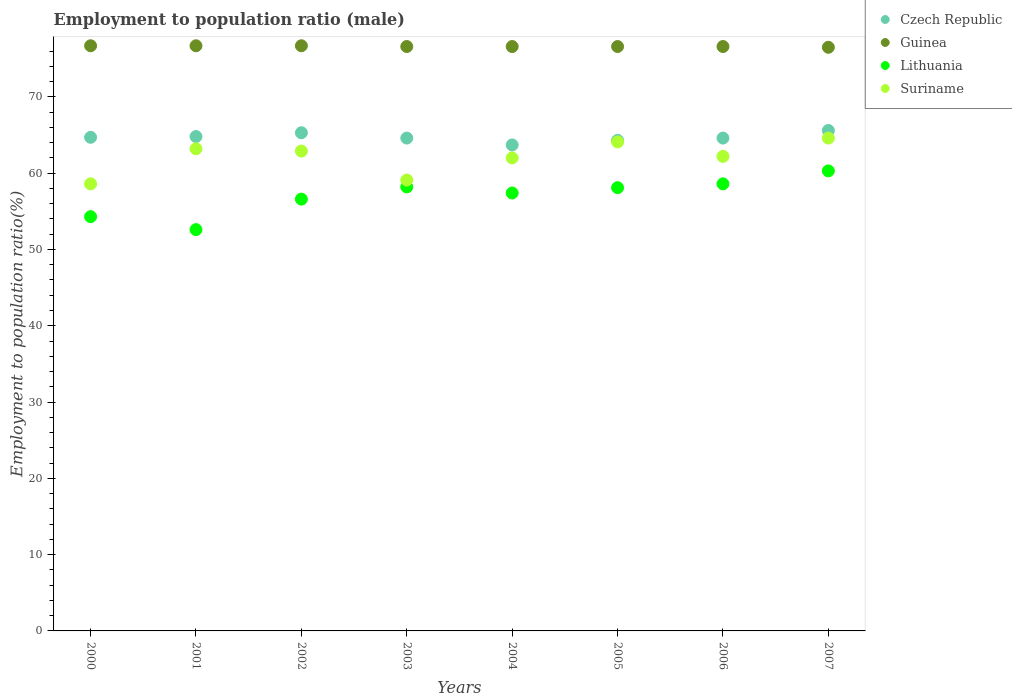What is the employment to population ratio in Suriname in 2006?
Give a very brief answer. 62.2. Across all years, what is the maximum employment to population ratio in Czech Republic?
Provide a short and direct response. 65.6. Across all years, what is the minimum employment to population ratio in Guinea?
Make the answer very short. 76.5. What is the total employment to population ratio in Guinea in the graph?
Ensure brevity in your answer.  613. What is the difference between the employment to population ratio in Lithuania in 2002 and that in 2005?
Your answer should be very brief. -1.5. What is the difference between the employment to population ratio in Suriname in 2003 and the employment to population ratio in Lithuania in 2005?
Provide a succinct answer. 1. What is the average employment to population ratio in Suriname per year?
Your answer should be very brief. 62.09. In the year 2002, what is the difference between the employment to population ratio in Guinea and employment to population ratio in Czech Republic?
Keep it short and to the point. 11.4. In how many years, is the employment to population ratio in Lithuania greater than 54 %?
Offer a very short reply. 7. What is the ratio of the employment to population ratio in Czech Republic in 2002 to that in 2003?
Keep it short and to the point. 1.01. Is the difference between the employment to population ratio in Guinea in 2001 and 2004 greater than the difference between the employment to population ratio in Czech Republic in 2001 and 2004?
Your answer should be very brief. No. What is the difference between the highest and the lowest employment to population ratio in Czech Republic?
Provide a short and direct response. 1.9. In how many years, is the employment to population ratio in Guinea greater than the average employment to population ratio in Guinea taken over all years?
Make the answer very short. 3. Is the sum of the employment to population ratio in Lithuania in 2001 and 2003 greater than the maximum employment to population ratio in Guinea across all years?
Provide a short and direct response. Yes. Is it the case that in every year, the sum of the employment to population ratio in Lithuania and employment to population ratio in Guinea  is greater than the sum of employment to population ratio in Suriname and employment to population ratio in Czech Republic?
Your answer should be very brief. Yes. How many dotlines are there?
Provide a succinct answer. 4. How many years are there in the graph?
Your answer should be very brief. 8. What is the difference between two consecutive major ticks on the Y-axis?
Provide a succinct answer. 10. Does the graph contain grids?
Offer a terse response. No. How many legend labels are there?
Keep it short and to the point. 4. What is the title of the graph?
Provide a succinct answer. Employment to population ratio (male). Does "Trinidad and Tobago" appear as one of the legend labels in the graph?
Ensure brevity in your answer.  No. What is the Employment to population ratio(%) of Czech Republic in 2000?
Your answer should be very brief. 64.7. What is the Employment to population ratio(%) of Guinea in 2000?
Offer a terse response. 76.7. What is the Employment to population ratio(%) of Lithuania in 2000?
Provide a short and direct response. 54.3. What is the Employment to population ratio(%) in Suriname in 2000?
Your answer should be compact. 58.6. What is the Employment to population ratio(%) of Czech Republic in 2001?
Your answer should be compact. 64.8. What is the Employment to population ratio(%) in Guinea in 2001?
Give a very brief answer. 76.7. What is the Employment to population ratio(%) of Lithuania in 2001?
Ensure brevity in your answer.  52.6. What is the Employment to population ratio(%) of Suriname in 2001?
Keep it short and to the point. 63.2. What is the Employment to population ratio(%) of Czech Republic in 2002?
Make the answer very short. 65.3. What is the Employment to population ratio(%) in Guinea in 2002?
Keep it short and to the point. 76.7. What is the Employment to population ratio(%) of Lithuania in 2002?
Your response must be concise. 56.6. What is the Employment to population ratio(%) of Suriname in 2002?
Ensure brevity in your answer.  62.9. What is the Employment to population ratio(%) of Czech Republic in 2003?
Your answer should be very brief. 64.6. What is the Employment to population ratio(%) of Guinea in 2003?
Your answer should be compact. 76.6. What is the Employment to population ratio(%) in Lithuania in 2003?
Provide a succinct answer. 58.2. What is the Employment to population ratio(%) in Suriname in 2003?
Provide a short and direct response. 59.1. What is the Employment to population ratio(%) of Czech Republic in 2004?
Your answer should be very brief. 63.7. What is the Employment to population ratio(%) in Guinea in 2004?
Make the answer very short. 76.6. What is the Employment to population ratio(%) of Lithuania in 2004?
Make the answer very short. 57.4. What is the Employment to population ratio(%) of Suriname in 2004?
Your answer should be very brief. 62. What is the Employment to population ratio(%) of Czech Republic in 2005?
Provide a succinct answer. 64.3. What is the Employment to population ratio(%) in Guinea in 2005?
Your answer should be compact. 76.6. What is the Employment to population ratio(%) of Lithuania in 2005?
Provide a short and direct response. 58.1. What is the Employment to population ratio(%) of Suriname in 2005?
Provide a succinct answer. 64.1. What is the Employment to population ratio(%) of Czech Republic in 2006?
Provide a short and direct response. 64.6. What is the Employment to population ratio(%) in Guinea in 2006?
Make the answer very short. 76.6. What is the Employment to population ratio(%) in Lithuania in 2006?
Your answer should be very brief. 58.6. What is the Employment to population ratio(%) in Suriname in 2006?
Ensure brevity in your answer.  62.2. What is the Employment to population ratio(%) of Czech Republic in 2007?
Your answer should be very brief. 65.6. What is the Employment to population ratio(%) of Guinea in 2007?
Offer a very short reply. 76.5. What is the Employment to population ratio(%) of Lithuania in 2007?
Your response must be concise. 60.3. What is the Employment to population ratio(%) in Suriname in 2007?
Provide a succinct answer. 64.6. Across all years, what is the maximum Employment to population ratio(%) of Czech Republic?
Keep it short and to the point. 65.6. Across all years, what is the maximum Employment to population ratio(%) in Guinea?
Keep it short and to the point. 76.7. Across all years, what is the maximum Employment to population ratio(%) of Lithuania?
Keep it short and to the point. 60.3. Across all years, what is the maximum Employment to population ratio(%) in Suriname?
Provide a short and direct response. 64.6. Across all years, what is the minimum Employment to population ratio(%) in Czech Republic?
Ensure brevity in your answer.  63.7. Across all years, what is the minimum Employment to population ratio(%) in Guinea?
Keep it short and to the point. 76.5. Across all years, what is the minimum Employment to population ratio(%) of Lithuania?
Your response must be concise. 52.6. Across all years, what is the minimum Employment to population ratio(%) of Suriname?
Provide a succinct answer. 58.6. What is the total Employment to population ratio(%) in Czech Republic in the graph?
Provide a succinct answer. 517.6. What is the total Employment to population ratio(%) in Guinea in the graph?
Ensure brevity in your answer.  613. What is the total Employment to population ratio(%) in Lithuania in the graph?
Offer a terse response. 456.1. What is the total Employment to population ratio(%) of Suriname in the graph?
Your response must be concise. 496.7. What is the difference between the Employment to population ratio(%) in Suriname in 2000 and that in 2001?
Your answer should be very brief. -4.6. What is the difference between the Employment to population ratio(%) in Czech Republic in 2000 and that in 2002?
Make the answer very short. -0.6. What is the difference between the Employment to population ratio(%) in Guinea in 2000 and that in 2002?
Keep it short and to the point. 0. What is the difference between the Employment to population ratio(%) in Lithuania in 2000 and that in 2002?
Give a very brief answer. -2.3. What is the difference between the Employment to population ratio(%) in Suriname in 2000 and that in 2003?
Make the answer very short. -0.5. What is the difference between the Employment to population ratio(%) of Guinea in 2000 and that in 2004?
Make the answer very short. 0.1. What is the difference between the Employment to population ratio(%) in Lithuania in 2000 and that in 2004?
Your answer should be very brief. -3.1. What is the difference between the Employment to population ratio(%) of Suriname in 2000 and that in 2004?
Make the answer very short. -3.4. What is the difference between the Employment to population ratio(%) in Czech Republic in 2000 and that in 2005?
Offer a terse response. 0.4. What is the difference between the Employment to population ratio(%) in Lithuania in 2000 and that in 2005?
Provide a short and direct response. -3.8. What is the difference between the Employment to population ratio(%) of Czech Republic in 2000 and that in 2006?
Your answer should be compact. 0.1. What is the difference between the Employment to population ratio(%) of Guinea in 2000 and that in 2006?
Offer a terse response. 0.1. What is the difference between the Employment to population ratio(%) of Lithuania in 2000 and that in 2006?
Make the answer very short. -4.3. What is the difference between the Employment to population ratio(%) in Suriname in 2000 and that in 2006?
Keep it short and to the point. -3.6. What is the difference between the Employment to population ratio(%) in Czech Republic in 2000 and that in 2007?
Make the answer very short. -0.9. What is the difference between the Employment to population ratio(%) in Guinea in 2000 and that in 2007?
Ensure brevity in your answer.  0.2. What is the difference between the Employment to population ratio(%) of Lithuania in 2000 and that in 2007?
Make the answer very short. -6. What is the difference between the Employment to population ratio(%) of Guinea in 2001 and that in 2002?
Provide a succinct answer. 0. What is the difference between the Employment to population ratio(%) in Lithuania in 2001 and that in 2002?
Offer a very short reply. -4. What is the difference between the Employment to population ratio(%) of Czech Republic in 2001 and that in 2003?
Provide a short and direct response. 0.2. What is the difference between the Employment to population ratio(%) in Suriname in 2001 and that in 2003?
Your response must be concise. 4.1. What is the difference between the Employment to population ratio(%) of Lithuania in 2001 and that in 2004?
Provide a succinct answer. -4.8. What is the difference between the Employment to population ratio(%) in Czech Republic in 2001 and that in 2005?
Your response must be concise. 0.5. What is the difference between the Employment to population ratio(%) of Guinea in 2001 and that in 2005?
Give a very brief answer. 0.1. What is the difference between the Employment to population ratio(%) in Suriname in 2001 and that in 2005?
Keep it short and to the point. -0.9. What is the difference between the Employment to population ratio(%) of Guinea in 2001 and that in 2006?
Provide a succinct answer. 0.1. What is the difference between the Employment to population ratio(%) in Guinea in 2001 and that in 2007?
Offer a terse response. 0.2. What is the difference between the Employment to population ratio(%) in Lithuania in 2001 and that in 2007?
Offer a terse response. -7.7. What is the difference between the Employment to population ratio(%) of Suriname in 2001 and that in 2007?
Provide a succinct answer. -1.4. What is the difference between the Employment to population ratio(%) of Czech Republic in 2002 and that in 2003?
Your response must be concise. 0.7. What is the difference between the Employment to population ratio(%) of Guinea in 2002 and that in 2003?
Your answer should be very brief. 0.1. What is the difference between the Employment to population ratio(%) of Suriname in 2002 and that in 2003?
Your response must be concise. 3.8. What is the difference between the Employment to population ratio(%) of Guinea in 2002 and that in 2004?
Ensure brevity in your answer.  0.1. What is the difference between the Employment to population ratio(%) in Czech Republic in 2002 and that in 2006?
Your answer should be compact. 0.7. What is the difference between the Employment to population ratio(%) of Lithuania in 2002 and that in 2006?
Make the answer very short. -2. What is the difference between the Employment to population ratio(%) of Guinea in 2002 and that in 2007?
Provide a succinct answer. 0.2. What is the difference between the Employment to population ratio(%) of Suriname in 2002 and that in 2007?
Make the answer very short. -1.7. What is the difference between the Employment to population ratio(%) of Czech Republic in 2003 and that in 2004?
Offer a terse response. 0.9. What is the difference between the Employment to population ratio(%) of Lithuania in 2003 and that in 2004?
Your answer should be very brief. 0.8. What is the difference between the Employment to population ratio(%) in Suriname in 2003 and that in 2004?
Give a very brief answer. -2.9. What is the difference between the Employment to population ratio(%) in Guinea in 2003 and that in 2005?
Your answer should be very brief. 0. What is the difference between the Employment to population ratio(%) in Lithuania in 2003 and that in 2005?
Ensure brevity in your answer.  0.1. What is the difference between the Employment to population ratio(%) in Czech Republic in 2003 and that in 2006?
Your answer should be very brief. 0. What is the difference between the Employment to population ratio(%) in Guinea in 2003 and that in 2006?
Ensure brevity in your answer.  0. What is the difference between the Employment to population ratio(%) of Suriname in 2003 and that in 2006?
Provide a succinct answer. -3.1. What is the difference between the Employment to population ratio(%) in Czech Republic in 2003 and that in 2007?
Offer a very short reply. -1. What is the difference between the Employment to population ratio(%) in Guinea in 2004 and that in 2005?
Ensure brevity in your answer.  0. What is the difference between the Employment to population ratio(%) in Czech Republic in 2004 and that in 2006?
Your answer should be compact. -0.9. What is the difference between the Employment to population ratio(%) of Czech Republic in 2004 and that in 2007?
Offer a terse response. -1.9. What is the difference between the Employment to population ratio(%) in Lithuania in 2004 and that in 2007?
Keep it short and to the point. -2.9. What is the difference between the Employment to population ratio(%) of Czech Republic in 2005 and that in 2006?
Your response must be concise. -0.3. What is the difference between the Employment to population ratio(%) in Suriname in 2005 and that in 2006?
Your answer should be very brief. 1.9. What is the difference between the Employment to population ratio(%) of Guinea in 2005 and that in 2007?
Offer a very short reply. 0.1. What is the difference between the Employment to population ratio(%) in Lithuania in 2005 and that in 2007?
Ensure brevity in your answer.  -2.2. What is the difference between the Employment to population ratio(%) of Guinea in 2006 and that in 2007?
Offer a very short reply. 0.1. What is the difference between the Employment to population ratio(%) in Lithuania in 2006 and that in 2007?
Keep it short and to the point. -1.7. What is the difference between the Employment to population ratio(%) of Suriname in 2006 and that in 2007?
Make the answer very short. -2.4. What is the difference between the Employment to population ratio(%) in Czech Republic in 2000 and the Employment to population ratio(%) in Guinea in 2001?
Provide a short and direct response. -12. What is the difference between the Employment to population ratio(%) of Czech Republic in 2000 and the Employment to population ratio(%) of Lithuania in 2001?
Make the answer very short. 12.1. What is the difference between the Employment to population ratio(%) of Czech Republic in 2000 and the Employment to population ratio(%) of Suriname in 2001?
Your answer should be compact. 1.5. What is the difference between the Employment to population ratio(%) of Guinea in 2000 and the Employment to population ratio(%) of Lithuania in 2001?
Your answer should be very brief. 24.1. What is the difference between the Employment to population ratio(%) of Guinea in 2000 and the Employment to population ratio(%) of Suriname in 2001?
Provide a succinct answer. 13.5. What is the difference between the Employment to population ratio(%) of Czech Republic in 2000 and the Employment to population ratio(%) of Guinea in 2002?
Your response must be concise. -12. What is the difference between the Employment to population ratio(%) in Guinea in 2000 and the Employment to population ratio(%) in Lithuania in 2002?
Offer a terse response. 20.1. What is the difference between the Employment to population ratio(%) of Guinea in 2000 and the Employment to population ratio(%) of Suriname in 2002?
Make the answer very short. 13.8. What is the difference between the Employment to population ratio(%) in Lithuania in 2000 and the Employment to population ratio(%) in Suriname in 2002?
Your response must be concise. -8.6. What is the difference between the Employment to population ratio(%) of Czech Republic in 2000 and the Employment to population ratio(%) of Lithuania in 2003?
Keep it short and to the point. 6.5. What is the difference between the Employment to population ratio(%) in Czech Republic in 2000 and the Employment to population ratio(%) in Suriname in 2003?
Your response must be concise. 5.6. What is the difference between the Employment to population ratio(%) of Lithuania in 2000 and the Employment to population ratio(%) of Suriname in 2003?
Your response must be concise. -4.8. What is the difference between the Employment to population ratio(%) of Czech Republic in 2000 and the Employment to population ratio(%) of Guinea in 2004?
Make the answer very short. -11.9. What is the difference between the Employment to population ratio(%) in Czech Republic in 2000 and the Employment to population ratio(%) in Lithuania in 2004?
Your answer should be very brief. 7.3. What is the difference between the Employment to population ratio(%) of Czech Republic in 2000 and the Employment to population ratio(%) of Suriname in 2004?
Give a very brief answer. 2.7. What is the difference between the Employment to population ratio(%) in Guinea in 2000 and the Employment to population ratio(%) in Lithuania in 2004?
Provide a succinct answer. 19.3. What is the difference between the Employment to population ratio(%) of Guinea in 2000 and the Employment to population ratio(%) of Suriname in 2004?
Give a very brief answer. 14.7. What is the difference between the Employment to population ratio(%) in Czech Republic in 2000 and the Employment to population ratio(%) in Guinea in 2005?
Provide a succinct answer. -11.9. What is the difference between the Employment to population ratio(%) of Czech Republic in 2000 and the Employment to population ratio(%) of Lithuania in 2005?
Make the answer very short. 6.6. What is the difference between the Employment to population ratio(%) of Czech Republic in 2000 and the Employment to population ratio(%) of Suriname in 2005?
Keep it short and to the point. 0.6. What is the difference between the Employment to population ratio(%) of Czech Republic in 2000 and the Employment to population ratio(%) of Guinea in 2007?
Make the answer very short. -11.8. What is the difference between the Employment to population ratio(%) in Czech Republic in 2000 and the Employment to population ratio(%) in Lithuania in 2007?
Ensure brevity in your answer.  4.4. What is the difference between the Employment to population ratio(%) of Czech Republic in 2000 and the Employment to population ratio(%) of Suriname in 2007?
Your answer should be compact. 0.1. What is the difference between the Employment to population ratio(%) in Guinea in 2000 and the Employment to population ratio(%) in Lithuania in 2007?
Make the answer very short. 16.4. What is the difference between the Employment to population ratio(%) in Czech Republic in 2001 and the Employment to population ratio(%) in Guinea in 2002?
Provide a succinct answer. -11.9. What is the difference between the Employment to population ratio(%) of Guinea in 2001 and the Employment to population ratio(%) of Lithuania in 2002?
Offer a terse response. 20.1. What is the difference between the Employment to population ratio(%) in Czech Republic in 2001 and the Employment to population ratio(%) in Suriname in 2003?
Provide a short and direct response. 5.7. What is the difference between the Employment to population ratio(%) in Guinea in 2001 and the Employment to population ratio(%) in Lithuania in 2003?
Keep it short and to the point. 18.5. What is the difference between the Employment to population ratio(%) in Guinea in 2001 and the Employment to population ratio(%) in Suriname in 2003?
Your answer should be compact. 17.6. What is the difference between the Employment to population ratio(%) in Czech Republic in 2001 and the Employment to population ratio(%) in Lithuania in 2004?
Your answer should be very brief. 7.4. What is the difference between the Employment to population ratio(%) of Czech Republic in 2001 and the Employment to population ratio(%) of Suriname in 2004?
Offer a very short reply. 2.8. What is the difference between the Employment to population ratio(%) in Guinea in 2001 and the Employment to population ratio(%) in Lithuania in 2004?
Give a very brief answer. 19.3. What is the difference between the Employment to population ratio(%) of Guinea in 2001 and the Employment to population ratio(%) of Suriname in 2004?
Make the answer very short. 14.7. What is the difference between the Employment to population ratio(%) in Lithuania in 2001 and the Employment to population ratio(%) in Suriname in 2004?
Give a very brief answer. -9.4. What is the difference between the Employment to population ratio(%) of Guinea in 2001 and the Employment to population ratio(%) of Lithuania in 2005?
Ensure brevity in your answer.  18.6. What is the difference between the Employment to population ratio(%) in Guinea in 2001 and the Employment to population ratio(%) in Suriname in 2005?
Your answer should be compact. 12.6. What is the difference between the Employment to population ratio(%) of Lithuania in 2001 and the Employment to population ratio(%) of Suriname in 2005?
Provide a short and direct response. -11.5. What is the difference between the Employment to population ratio(%) in Czech Republic in 2001 and the Employment to population ratio(%) in Guinea in 2006?
Offer a terse response. -11.8. What is the difference between the Employment to population ratio(%) of Lithuania in 2001 and the Employment to population ratio(%) of Suriname in 2006?
Provide a succinct answer. -9.6. What is the difference between the Employment to population ratio(%) in Lithuania in 2001 and the Employment to population ratio(%) in Suriname in 2007?
Your answer should be compact. -12. What is the difference between the Employment to population ratio(%) in Czech Republic in 2002 and the Employment to population ratio(%) in Lithuania in 2003?
Keep it short and to the point. 7.1. What is the difference between the Employment to population ratio(%) in Czech Republic in 2002 and the Employment to population ratio(%) in Suriname in 2003?
Make the answer very short. 6.2. What is the difference between the Employment to population ratio(%) of Guinea in 2002 and the Employment to population ratio(%) of Lithuania in 2003?
Your answer should be compact. 18.5. What is the difference between the Employment to population ratio(%) of Guinea in 2002 and the Employment to population ratio(%) of Suriname in 2003?
Provide a short and direct response. 17.6. What is the difference between the Employment to population ratio(%) of Lithuania in 2002 and the Employment to population ratio(%) of Suriname in 2003?
Your answer should be compact. -2.5. What is the difference between the Employment to population ratio(%) of Czech Republic in 2002 and the Employment to population ratio(%) of Lithuania in 2004?
Provide a short and direct response. 7.9. What is the difference between the Employment to population ratio(%) of Guinea in 2002 and the Employment to population ratio(%) of Lithuania in 2004?
Your answer should be very brief. 19.3. What is the difference between the Employment to population ratio(%) of Lithuania in 2002 and the Employment to population ratio(%) of Suriname in 2004?
Offer a very short reply. -5.4. What is the difference between the Employment to population ratio(%) of Guinea in 2002 and the Employment to population ratio(%) of Lithuania in 2005?
Make the answer very short. 18.6. What is the difference between the Employment to population ratio(%) of Czech Republic in 2002 and the Employment to population ratio(%) of Guinea in 2006?
Give a very brief answer. -11.3. What is the difference between the Employment to population ratio(%) in Czech Republic in 2002 and the Employment to population ratio(%) in Lithuania in 2006?
Your answer should be compact. 6.7. What is the difference between the Employment to population ratio(%) of Guinea in 2002 and the Employment to population ratio(%) of Lithuania in 2006?
Ensure brevity in your answer.  18.1. What is the difference between the Employment to population ratio(%) of Czech Republic in 2002 and the Employment to population ratio(%) of Guinea in 2007?
Your answer should be compact. -11.2. What is the difference between the Employment to population ratio(%) of Guinea in 2002 and the Employment to population ratio(%) of Lithuania in 2007?
Keep it short and to the point. 16.4. What is the difference between the Employment to population ratio(%) in Guinea in 2002 and the Employment to population ratio(%) in Suriname in 2007?
Your answer should be very brief. 12.1. What is the difference between the Employment to population ratio(%) in Lithuania in 2002 and the Employment to population ratio(%) in Suriname in 2007?
Make the answer very short. -8. What is the difference between the Employment to population ratio(%) in Guinea in 2003 and the Employment to population ratio(%) in Suriname in 2004?
Offer a very short reply. 14.6. What is the difference between the Employment to population ratio(%) in Czech Republic in 2003 and the Employment to population ratio(%) in Lithuania in 2005?
Offer a very short reply. 6.5. What is the difference between the Employment to population ratio(%) in Czech Republic in 2003 and the Employment to population ratio(%) in Suriname in 2005?
Offer a very short reply. 0.5. What is the difference between the Employment to population ratio(%) of Guinea in 2003 and the Employment to population ratio(%) of Suriname in 2005?
Your answer should be very brief. 12.5. What is the difference between the Employment to population ratio(%) of Czech Republic in 2003 and the Employment to population ratio(%) of Guinea in 2006?
Keep it short and to the point. -12. What is the difference between the Employment to population ratio(%) of Guinea in 2003 and the Employment to population ratio(%) of Lithuania in 2006?
Provide a succinct answer. 18. What is the difference between the Employment to population ratio(%) of Czech Republic in 2003 and the Employment to population ratio(%) of Guinea in 2007?
Your response must be concise. -11.9. What is the difference between the Employment to population ratio(%) in Guinea in 2003 and the Employment to population ratio(%) in Lithuania in 2007?
Provide a short and direct response. 16.3. What is the difference between the Employment to population ratio(%) in Czech Republic in 2004 and the Employment to population ratio(%) in Guinea in 2005?
Your response must be concise. -12.9. What is the difference between the Employment to population ratio(%) in Czech Republic in 2004 and the Employment to population ratio(%) in Suriname in 2005?
Provide a succinct answer. -0.4. What is the difference between the Employment to population ratio(%) in Guinea in 2004 and the Employment to population ratio(%) in Lithuania in 2005?
Keep it short and to the point. 18.5. What is the difference between the Employment to population ratio(%) in Lithuania in 2004 and the Employment to population ratio(%) in Suriname in 2005?
Your answer should be very brief. -6.7. What is the difference between the Employment to population ratio(%) in Czech Republic in 2004 and the Employment to population ratio(%) in Suriname in 2006?
Your response must be concise. 1.5. What is the difference between the Employment to population ratio(%) of Guinea in 2004 and the Employment to population ratio(%) of Lithuania in 2006?
Provide a short and direct response. 18. What is the difference between the Employment to population ratio(%) of Lithuania in 2004 and the Employment to population ratio(%) of Suriname in 2006?
Your answer should be very brief. -4.8. What is the difference between the Employment to population ratio(%) of Guinea in 2004 and the Employment to population ratio(%) of Lithuania in 2007?
Offer a very short reply. 16.3. What is the difference between the Employment to population ratio(%) of Czech Republic in 2005 and the Employment to population ratio(%) of Guinea in 2006?
Your answer should be very brief. -12.3. What is the difference between the Employment to population ratio(%) of Czech Republic in 2005 and the Employment to population ratio(%) of Lithuania in 2006?
Your answer should be very brief. 5.7. What is the difference between the Employment to population ratio(%) in Guinea in 2005 and the Employment to population ratio(%) in Lithuania in 2006?
Provide a short and direct response. 18. What is the difference between the Employment to population ratio(%) in Lithuania in 2005 and the Employment to population ratio(%) in Suriname in 2006?
Your answer should be compact. -4.1. What is the difference between the Employment to population ratio(%) in Czech Republic in 2005 and the Employment to population ratio(%) in Guinea in 2007?
Make the answer very short. -12.2. What is the difference between the Employment to population ratio(%) of Czech Republic in 2005 and the Employment to population ratio(%) of Suriname in 2007?
Keep it short and to the point. -0.3. What is the difference between the Employment to population ratio(%) in Lithuania in 2005 and the Employment to population ratio(%) in Suriname in 2007?
Keep it short and to the point. -6.5. What is the difference between the Employment to population ratio(%) in Guinea in 2006 and the Employment to population ratio(%) in Lithuania in 2007?
Your response must be concise. 16.3. What is the difference between the Employment to population ratio(%) of Guinea in 2006 and the Employment to population ratio(%) of Suriname in 2007?
Give a very brief answer. 12. What is the difference between the Employment to population ratio(%) of Lithuania in 2006 and the Employment to population ratio(%) of Suriname in 2007?
Your response must be concise. -6. What is the average Employment to population ratio(%) of Czech Republic per year?
Provide a short and direct response. 64.7. What is the average Employment to population ratio(%) in Guinea per year?
Provide a short and direct response. 76.62. What is the average Employment to population ratio(%) of Lithuania per year?
Make the answer very short. 57.01. What is the average Employment to population ratio(%) of Suriname per year?
Offer a very short reply. 62.09. In the year 2000, what is the difference between the Employment to population ratio(%) of Czech Republic and Employment to population ratio(%) of Lithuania?
Your answer should be compact. 10.4. In the year 2000, what is the difference between the Employment to population ratio(%) in Guinea and Employment to population ratio(%) in Lithuania?
Provide a succinct answer. 22.4. In the year 2001, what is the difference between the Employment to population ratio(%) in Czech Republic and Employment to population ratio(%) in Lithuania?
Ensure brevity in your answer.  12.2. In the year 2001, what is the difference between the Employment to population ratio(%) in Guinea and Employment to population ratio(%) in Lithuania?
Offer a very short reply. 24.1. In the year 2001, what is the difference between the Employment to population ratio(%) of Guinea and Employment to population ratio(%) of Suriname?
Provide a short and direct response. 13.5. In the year 2002, what is the difference between the Employment to population ratio(%) in Guinea and Employment to population ratio(%) in Lithuania?
Make the answer very short. 20.1. In the year 2003, what is the difference between the Employment to population ratio(%) in Czech Republic and Employment to population ratio(%) in Lithuania?
Your answer should be very brief. 6.4. In the year 2003, what is the difference between the Employment to population ratio(%) in Guinea and Employment to population ratio(%) in Lithuania?
Your answer should be compact. 18.4. In the year 2004, what is the difference between the Employment to population ratio(%) of Czech Republic and Employment to population ratio(%) of Lithuania?
Offer a very short reply. 6.3. In the year 2005, what is the difference between the Employment to population ratio(%) of Czech Republic and Employment to population ratio(%) of Guinea?
Keep it short and to the point. -12.3. In the year 2005, what is the difference between the Employment to population ratio(%) in Czech Republic and Employment to population ratio(%) in Lithuania?
Provide a succinct answer. 6.2. In the year 2005, what is the difference between the Employment to population ratio(%) of Guinea and Employment to population ratio(%) of Lithuania?
Give a very brief answer. 18.5. In the year 2006, what is the difference between the Employment to population ratio(%) of Czech Republic and Employment to population ratio(%) of Guinea?
Provide a short and direct response. -12. In the year 2006, what is the difference between the Employment to population ratio(%) in Czech Republic and Employment to population ratio(%) in Suriname?
Keep it short and to the point. 2.4. In the year 2007, what is the difference between the Employment to population ratio(%) of Czech Republic and Employment to population ratio(%) of Guinea?
Offer a terse response. -10.9. In the year 2007, what is the difference between the Employment to population ratio(%) in Czech Republic and Employment to population ratio(%) in Lithuania?
Your answer should be compact. 5.3. In the year 2007, what is the difference between the Employment to population ratio(%) of Guinea and Employment to population ratio(%) of Suriname?
Offer a terse response. 11.9. What is the ratio of the Employment to population ratio(%) of Lithuania in 2000 to that in 2001?
Make the answer very short. 1.03. What is the ratio of the Employment to population ratio(%) in Suriname in 2000 to that in 2001?
Offer a very short reply. 0.93. What is the ratio of the Employment to population ratio(%) in Czech Republic in 2000 to that in 2002?
Provide a short and direct response. 0.99. What is the ratio of the Employment to population ratio(%) in Guinea in 2000 to that in 2002?
Offer a terse response. 1. What is the ratio of the Employment to population ratio(%) of Lithuania in 2000 to that in 2002?
Keep it short and to the point. 0.96. What is the ratio of the Employment to population ratio(%) in Suriname in 2000 to that in 2002?
Make the answer very short. 0.93. What is the ratio of the Employment to population ratio(%) in Czech Republic in 2000 to that in 2003?
Ensure brevity in your answer.  1. What is the ratio of the Employment to population ratio(%) of Lithuania in 2000 to that in 2003?
Ensure brevity in your answer.  0.93. What is the ratio of the Employment to population ratio(%) in Suriname in 2000 to that in 2003?
Offer a very short reply. 0.99. What is the ratio of the Employment to population ratio(%) in Czech Republic in 2000 to that in 2004?
Your answer should be very brief. 1.02. What is the ratio of the Employment to population ratio(%) of Guinea in 2000 to that in 2004?
Your answer should be compact. 1. What is the ratio of the Employment to population ratio(%) of Lithuania in 2000 to that in 2004?
Your answer should be very brief. 0.95. What is the ratio of the Employment to population ratio(%) of Suriname in 2000 to that in 2004?
Your answer should be very brief. 0.95. What is the ratio of the Employment to population ratio(%) of Lithuania in 2000 to that in 2005?
Offer a terse response. 0.93. What is the ratio of the Employment to population ratio(%) in Suriname in 2000 to that in 2005?
Provide a short and direct response. 0.91. What is the ratio of the Employment to population ratio(%) in Czech Republic in 2000 to that in 2006?
Offer a very short reply. 1. What is the ratio of the Employment to population ratio(%) of Lithuania in 2000 to that in 2006?
Offer a very short reply. 0.93. What is the ratio of the Employment to population ratio(%) in Suriname in 2000 to that in 2006?
Provide a short and direct response. 0.94. What is the ratio of the Employment to population ratio(%) of Czech Republic in 2000 to that in 2007?
Give a very brief answer. 0.99. What is the ratio of the Employment to population ratio(%) in Lithuania in 2000 to that in 2007?
Provide a succinct answer. 0.9. What is the ratio of the Employment to population ratio(%) in Suriname in 2000 to that in 2007?
Offer a very short reply. 0.91. What is the ratio of the Employment to population ratio(%) in Czech Republic in 2001 to that in 2002?
Make the answer very short. 0.99. What is the ratio of the Employment to population ratio(%) of Lithuania in 2001 to that in 2002?
Your answer should be very brief. 0.93. What is the ratio of the Employment to population ratio(%) in Suriname in 2001 to that in 2002?
Provide a succinct answer. 1. What is the ratio of the Employment to population ratio(%) of Czech Republic in 2001 to that in 2003?
Provide a short and direct response. 1. What is the ratio of the Employment to population ratio(%) in Guinea in 2001 to that in 2003?
Make the answer very short. 1. What is the ratio of the Employment to population ratio(%) in Lithuania in 2001 to that in 2003?
Provide a short and direct response. 0.9. What is the ratio of the Employment to population ratio(%) in Suriname in 2001 to that in 2003?
Your answer should be very brief. 1.07. What is the ratio of the Employment to population ratio(%) in Czech Republic in 2001 to that in 2004?
Your answer should be compact. 1.02. What is the ratio of the Employment to population ratio(%) of Guinea in 2001 to that in 2004?
Make the answer very short. 1. What is the ratio of the Employment to population ratio(%) in Lithuania in 2001 to that in 2004?
Provide a succinct answer. 0.92. What is the ratio of the Employment to population ratio(%) of Suriname in 2001 to that in 2004?
Your answer should be very brief. 1.02. What is the ratio of the Employment to population ratio(%) of Czech Republic in 2001 to that in 2005?
Your answer should be very brief. 1.01. What is the ratio of the Employment to population ratio(%) in Guinea in 2001 to that in 2005?
Ensure brevity in your answer.  1. What is the ratio of the Employment to population ratio(%) in Lithuania in 2001 to that in 2005?
Provide a succinct answer. 0.91. What is the ratio of the Employment to population ratio(%) in Suriname in 2001 to that in 2005?
Your answer should be very brief. 0.99. What is the ratio of the Employment to population ratio(%) in Lithuania in 2001 to that in 2006?
Offer a terse response. 0.9. What is the ratio of the Employment to population ratio(%) in Suriname in 2001 to that in 2006?
Keep it short and to the point. 1.02. What is the ratio of the Employment to population ratio(%) of Czech Republic in 2001 to that in 2007?
Make the answer very short. 0.99. What is the ratio of the Employment to population ratio(%) of Guinea in 2001 to that in 2007?
Provide a succinct answer. 1. What is the ratio of the Employment to population ratio(%) in Lithuania in 2001 to that in 2007?
Ensure brevity in your answer.  0.87. What is the ratio of the Employment to population ratio(%) in Suriname in 2001 to that in 2007?
Give a very brief answer. 0.98. What is the ratio of the Employment to population ratio(%) in Czech Republic in 2002 to that in 2003?
Offer a terse response. 1.01. What is the ratio of the Employment to population ratio(%) in Guinea in 2002 to that in 2003?
Provide a succinct answer. 1. What is the ratio of the Employment to population ratio(%) in Lithuania in 2002 to that in 2003?
Keep it short and to the point. 0.97. What is the ratio of the Employment to population ratio(%) of Suriname in 2002 to that in 2003?
Offer a terse response. 1.06. What is the ratio of the Employment to population ratio(%) of Czech Republic in 2002 to that in 2004?
Provide a succinct answer. 1.03. What is the ratio of the Employment to population ratio(%) of Guinea in 2002 to that in 2004?
Give a very brief answer. 1. What is the ratio of the Employment to population ratio(%) in Lithuania in 2002 to that in 2004?
Ensure brevity in your answer.  0.99. What is the ratio of the Employment to population ratio(%) in Suriname in 2002 to that in 2004?
Offer a very short reply. 1.01. What is the ratio of the Employment to population ratio(%) of Czech Republic in 2002 to that in 2005?
Your answer should be very brief. 1.02. What is the ratio of the Employment to population ratio(%) in Guinea in 2002 to that in 2005?
Keep it short and to the point. 1. What is the ratio of the Employment to population ratio(%) of Lithuania in 2002 to that in 2005?
Offer a very short reply. 0.97. What is the ratio of the Employment to population ratio(%) in Suriname in 2002 to that in 2005?
Ensure brevity in your answer.  0.98. What is the ratio of the Employment to population ratio(%) in Czech Republic in 2002 to that in 2006?
Keep it short and to the point. 1.01. What is the ratio of the Employment to population ratio(%) in Lithuania in 2002 to that in 2006?
Your answer should be compact. 0.97. What is the ratio of the Employment to population ratio(%) in Suriname in 2002 to that in 2006?
Ensure brevity in your answer.  1.01. What is the ratio of the Employment to population ratio(%) in Guinea in 2002 to that in 2007?
Make the answer very short. 1. What is the ratio of the Employment to population ratio(%) in Lithuania in 2002 to that in 2007?
Provide a short and direct response. 0.94. What is the ratio of the Employment to population ratio(%) in Suriname in 2002 to that in 2007?
Offer a very short reply. 0.97. What is the ratio of the Employment to population ratio(%) in Czech Republic in 2003 to that in 2004?
Offer a terse response. 1.01. What is the ratio of the Employment to population ratio(%) in Lithuania in 2003 to that in 2004?
Your answer should be very brief. 1.01. What is the ratio of the Employment to population ratio(%) of Suriname in 2003 to that in 2004?
Give a very brief answer. 0.95. What is the ratio of the Employment to population ratio(%) in Guinea in 2003 to that in 2005?
Offer a terse response. 1. What is the ratio of the Employment to population ratio(%) in Lithuania in 2003 to that in 2005?
Keep it short and to the point. 1. What is the ratio of the Employment to population ratio(%) in Suriname in 2003 to that in 2005?
Keep it short and to the point. 0.92. What is the ratio of the Employment to population ratio(%) in Guinea in 2003 to that in 2006?
Your answer should be compact. 1. What is the ratio of the Employment to population ratio(%) of Lithuania in 2003 to that in 2006?
Offer a terse response. 0.99. What is the ratio of the Employment to population ratio(%) of Suriname in 2003 to that in 2006?
Provide a short and direct response. 0.95. What is the ratio of the Employment to population ratio(%) in Guinea in 2003 to that in 2007?
Keep it short and to the point. 1. What is the ratio of the Employment to population ratio(%) in Lithuania in 2003 to that in 2007?
Keep it short and to the point. 0.97. What is the ratio of the Employment to population ratio(%) in Suriname in 2003 to that in 2007?
Provide a short and direct response. 0.91. What is the ratio of the Employment to population ratio(%) in Czech Republic in 2004 to that in 2005?
Give a very brief answer. 0.99. What is the ratio of the Employment to population ratio(%) in Suriname in 2004 to that in 2005?
Provide a short and direct response. 0.97. What is the ratio of the Employment to population ratio(%) in Czech Republic in 2004 to that in 2006?
Keep it short and to the point. 0.99. What is the ratio of the Employment to population ratio(%) of Lithuania in 2004 to that in 2006?
Your response must be concise. 0.98. What is the ratio of the Employment to population ratio(%) of Suriname in 2004 to that in 2006?
Your response must be concise. 1. What is the ratio of the Employment to population ratio(%) in Lithuania in 2004 to that in 2007?
Provide a succinct answer. 0.95. What is the ratio of the Employment to population ratio(%) of Suriname in 2004 to that in 2007?
Give a very brief answer. 0.96. What is the ratio of the Employment to population ratio(%) of Suriname in 2005 to that in 2006?
Provide a short and direct response. 1.03. What is the ratio of the Employment to population ratio(%) of Czech Republic in 2005 to that in 2007?
Offer a terse response. 0.98. What is the ratio of the Employment to population ratio(%) in Guinea in 2005 to that in 2007?
Your response must be concise. 1. What is the ratio of the Employment to population ratio(%) of Lithuania in 2005 to that in 2007?
Ensure brevity in your answer.  0.96. What is the ratio of the Employment to population ratio(%) in Suriname in 2005 to that in 2007?
Keep it short and to the point. 0.99. What is the ratio of the Employment to population ratio(%) in Guinea in 2006 to that in 2007?
Give a very brief answer. 1. What is the ratio of the Employment to population ratio(%) in Lithuania in 2006 to that in 2007?
Provide a succinct answer. 0.97. What is the ratio of the Employment to population ratio(%) of Suriname in 2006 to that in 2007?
Give a very brief answer. 0.96. What is the difference between the highest and the second highest Employment to population ratio(%) of Czech Republic?
Keep it short and to the point. 0.3. What is the difference between the highest and the second highest Employment to population ratio(%) in Guinea?
Offer a very short reply. 0. What is the difference between the highest and the second highest Employment to population ratio(%) in Lithuania?
Offer a very short reply. 1.7. What is the difference between the highest and the second highest Employment to population ratio(%) of Suriname?
Ensure brevity in your answer.  0.5. What is the difference between the highest and the lowest Employment to population ratio(%) in Czech Republic?
Ensure brevity in your answer.  1.9. What is the difference between the highest and the lowest Employment to population ratio(%) in Lithuania?
Give a very brief answer. 7.7. What is the difference between the highest and the lowest Employment to population ratio(%) in Suriname?
Provide a succinct answer. 6. 